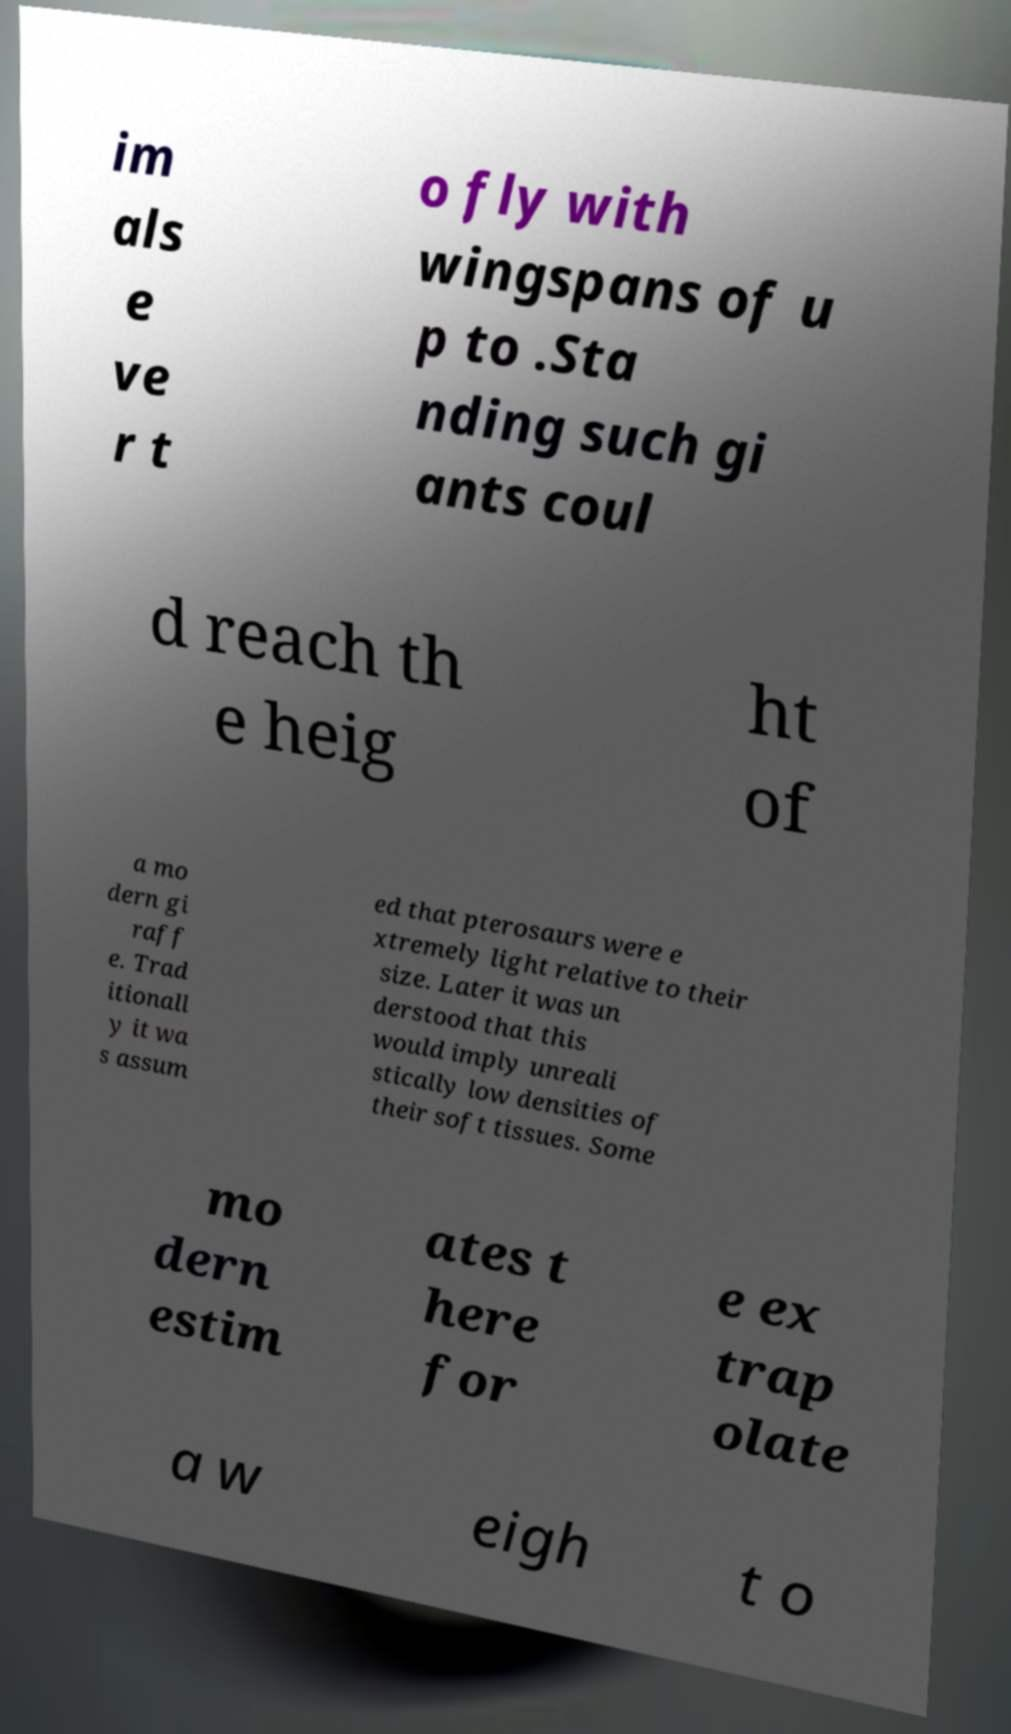For documentation purposes, I need the text within this image transcribed. Could you provide that? im als e ve r t o fly with wingspans of u p to .Sta nding such gi ants coul d reach th e heig ht of a mo dern gi raff e. Trad itionall y it wa s assum ed that pterosaurs were e xtremely light relative to their size. Later it was un derstood that this would imply unreali stically low densities of their soft tissues. Some mo dern estim ates t here for e ex trap olate a w eigh t o 